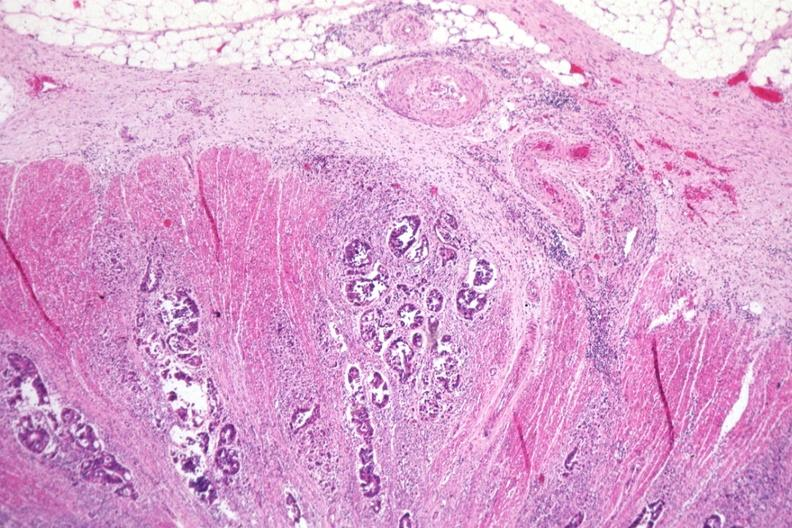what is present?
Answer the question using a single word or phrase. Gastrointestinal 